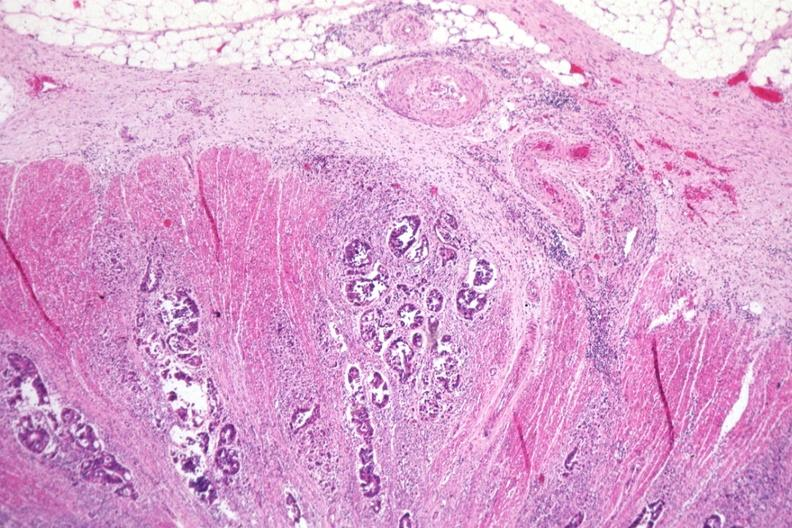what is present?
Answer the question using a single word or phrase. Gastrointestinal 